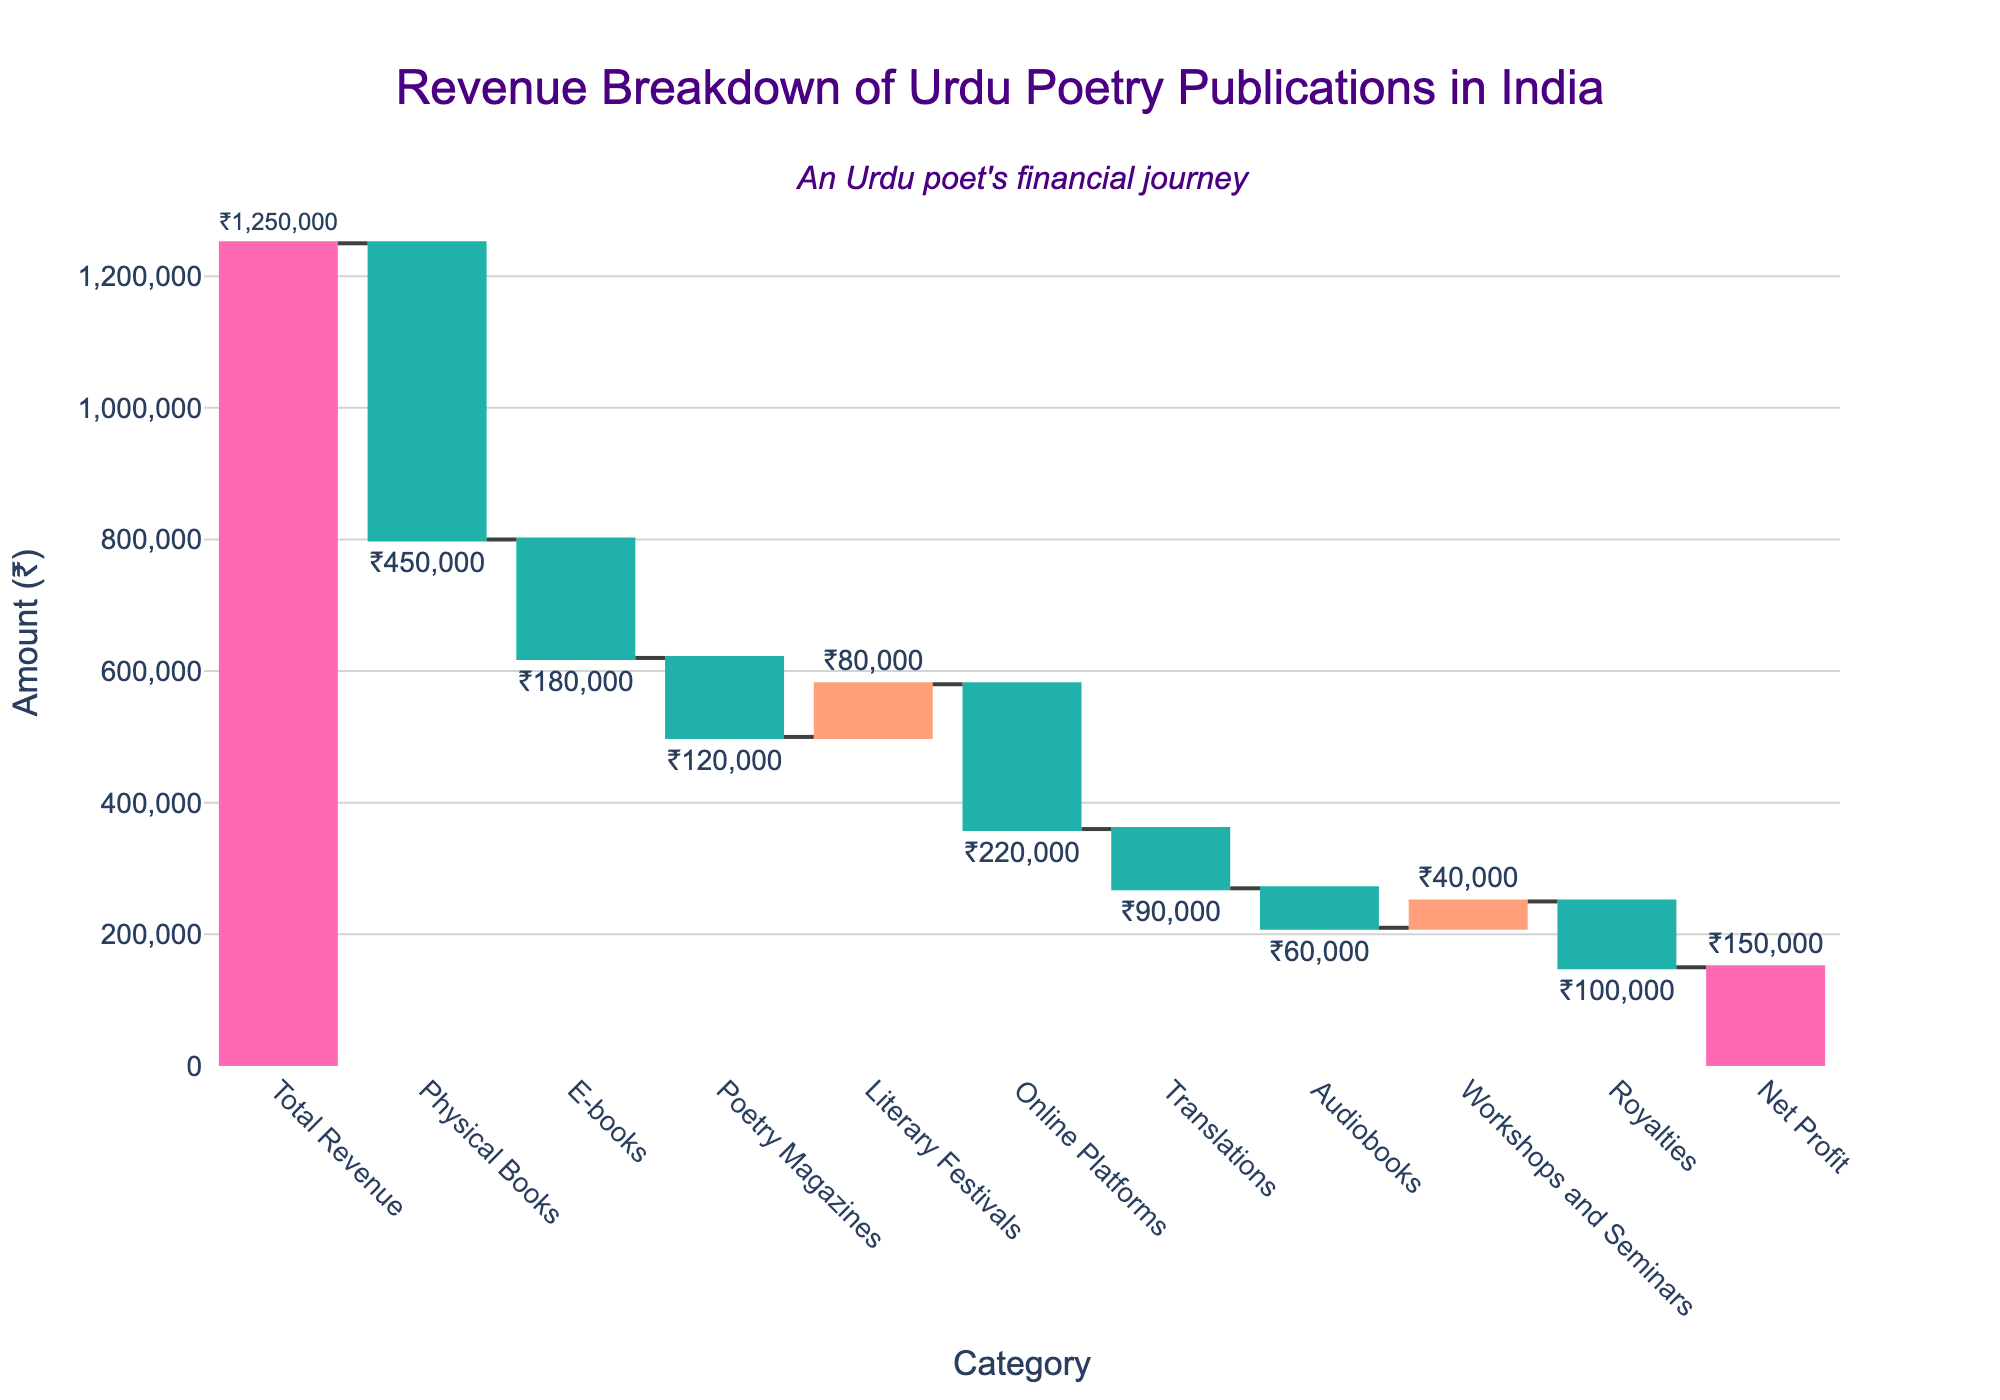What is the total revenue for Urdu poetry publications in India? The chart shows the initial bar labeled as "Total Revenue," which represents the total generated revenue.
Answer: ₹1,250,000 Which category contributed the most to the revenue? The category with the positive bar having the highest value represents the greatest contribution. "Literary Festivals" is the highest positive bar.
Answer: Literary Festivals What is the net profit for Urdu poetry publications? The final bar labeled "Net Profit" represents the net profit after all the additions and deductions.
Answer: ₹150,000 How much revenue was gained from literary festivals? The bar labeled "Literary Festivals" with a positive value indicates the revenue gained.
Answer: ₹80,000 What was the impact of royalties on the revenue? The bar labeled "Royalties" shows a negative value, indicating a deduction from the revenue.
Answer: -₹100,000 Which category had the least negative impact on the revenue? The smallest value among the negative bars represents the least negative impact. "Audiobooks" has the smallest negative value.
Answer: Audiobooks How much revenue was lost from online platforms? The bar labeled "Online Platforms" with a negative value indicates the revenue lost.
Answer: -₹220,000 What is the combined revenue from workshops and seminars? The bar labeled "Workshops and Seminars" with a positive value indicates the revenue gained.
Answer: ₹40,000 Compare the revenue from physical books and e-books. Which had a higher negative impact? By comparing the heights of the negative bars labeled "Physical Books" and "E-books," we see that "Physical Books" had a higher negative impact.
Answer: Physical Books What is the total revenue contribution from positive categories? Add the positive values: Literary Festivals (₹80,000) + Workshops and Seminars (₹40,000) = ₹120,000.
Answer: ₹120,000 